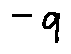<formula> <loc_0><loc_0><loc_500><loc_500>- q</formula> 